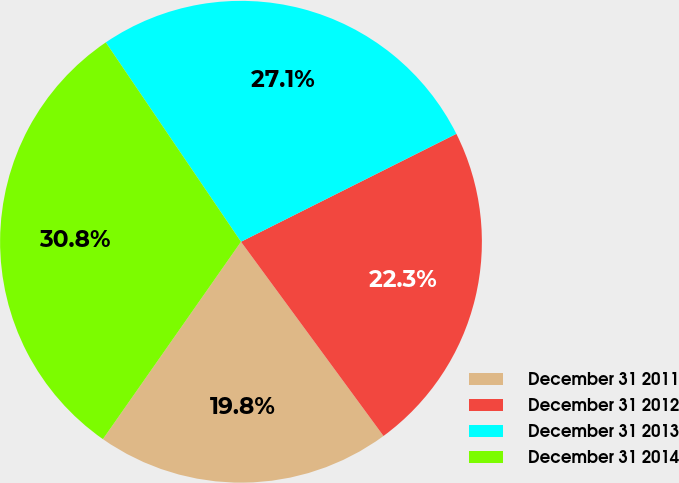Convert chart to OTSL. <chart><loc_0><loc_0><loc_500><loc_500><pie_chart><fcel>December 31 2011<fcel>December 31 2012<fcel>December 31 2013<fcel>December 31 2014<nl><fcel>19.79%<fcel>22.32%<fcel>27.09%<fcel>30.8%<nl></chart> 